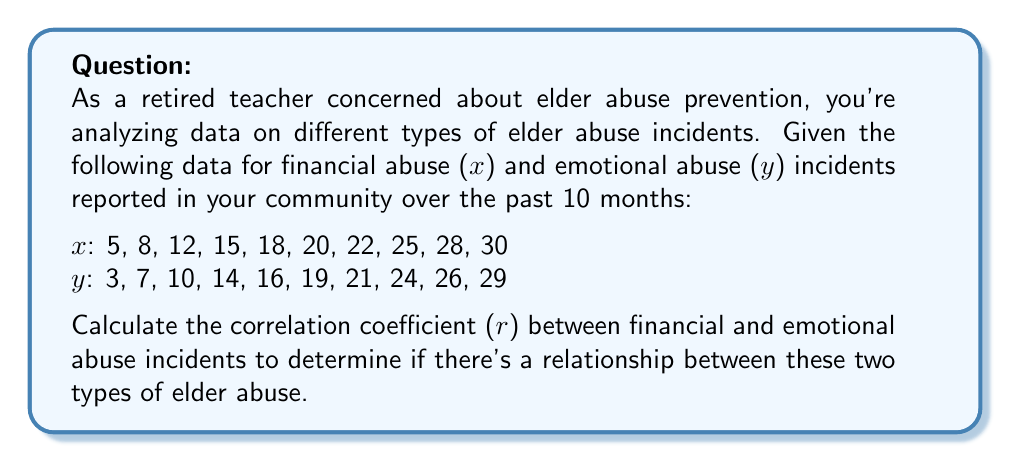Show me your answer to this math problem. To calculate the correlation coefficient (r), we'll use the formula:

$$ r = \frac{\sum_{i=1}^{n} (x_i - \bar{x})(y_i - \bar{y})}{\sqrt{\sum_{i=1}^{n} (x_i - \bar{x})^2 \sum_{i=1}^{n} (y_i - \bar{y})^2}} $$

Step 1: Calculate the means $\bar{x}$ and $\bar{y}$
$\bar{x} = \frac{5 + 8 + 12 + 15 + 18 + 20 + 22 + 25 + 28 + 30}{10} = 18.3$
$\bar{y} = \frac{3 + 7 + 10 + 14 + 16 + 19 + 21 + 24 + 26 + 29}{10} = 16.9$

Step 2: Calculate $(x_i - \bar{x})$, $(y_i - \bar{y})$, $(x_i - \bar{x})^2$, $(y_i - \bar{y})^2$, and $(x_i - \bar{x})(y_i - \bar{y})$ for each pair of data points.

Step 3: Sum up the results from Step 2
$\sum (x_i - \bar{x})(y_i - \bar{y}) = 1064.6$
$\sum (x_i - \bar{x})^2 = 1124.1$
$\sum (y_i - \bar{y})^2 = 1016.9$

Step 4: Apply the correlation coefficient formula
$$ r = \frac{1064.6}{\sqrt{1124.1 \times 1016.9}} = \frac{1064.6}{1069.5} \approx 0.9954 $$
Answer: $r \approx 0.9954$ 